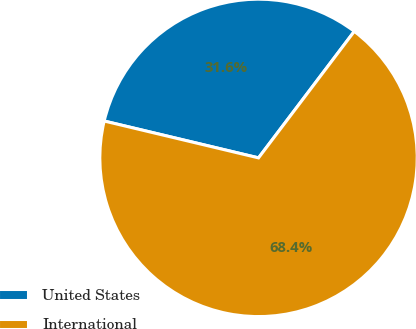<chart> <loc_0><loc_0><loc_500><loc_500><pie_chart><fcel>United States<fcel>International<nl><fcel>31.58%<fcel>68.42%<nl></chart> 